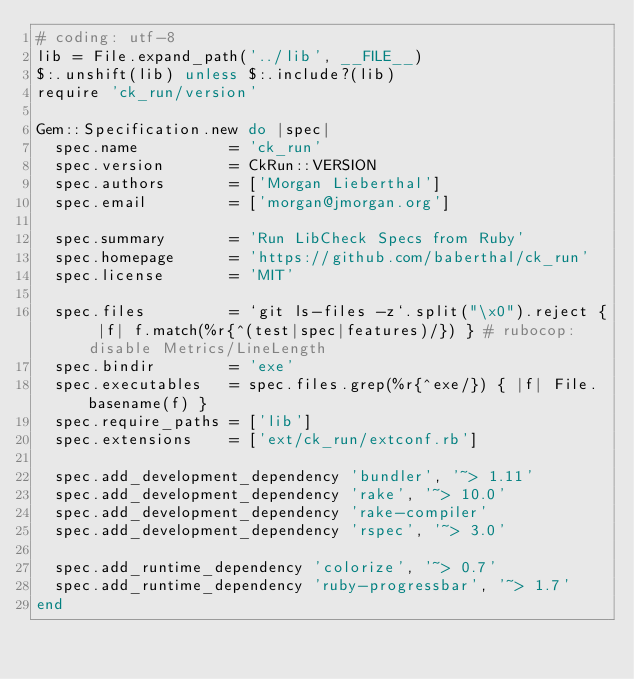Convert code to text. <code><loc_0><loc_0><loc_500><loc_500><_Ruby_># coding: utf-8
lib = File.expand_path('../lib', __FILE__)
$:.unshift(lib) unless $:.include?(lib)
require 'ck_run/version'

Gem::Specification.new do |spec|
  spec.name          = 'ck_run'
  spec.version       = CkRun::VERSION
  spec.authors       = ['Morgan Lieberthal']
  spec.email         = ['morgan@jmorgan.org']

  spec.summary       = 'Run LibCheck Specs from Ruby'
  spec.homepage      = 'https://github.com/baberthal/ck_run'
  spec.license       = 'MIT'

  spec.files         = `git ls-files -z`.split("\x0").reject { |f| f.match(%r{^(test|spec|features)/}) } # rubocop:disable Metrics/LineLength
  spec.bindir        = 'exe'
  spec.executables   = spec.files.grep(%r{^exe/}) { |f| File.basename(f) }
  spec.require_paths = ['lib']
  spec.extensions    = ['ext/ck_run/extconf.rb']

  spec.add_development_dependency 'bundler', '~> 1.11'
  spec.add_development_dependency 'rake', '~> 10.0'
  spec.add_development_dependency 'rake-compiler'
  spec.add_development_dependency 'rspec', '~> 3.0'

  spec.add_runtime_dependency 'colorize', '~> 0.7'
  spec.add_runtime_dependency 'ruby-progressbar', '~> 1.7'
end
</code> 